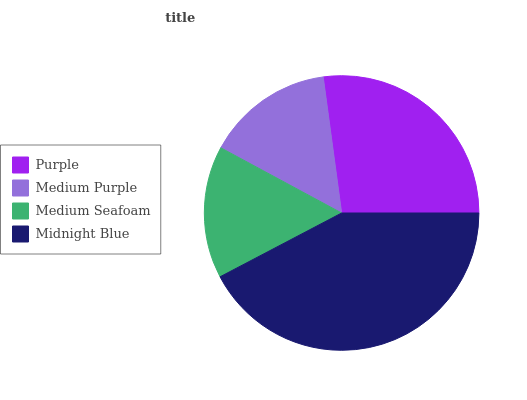Is Medium Purple the minimum?
Answer yes or no. Yes. Is Midnight Blue the maximum?
Answer yes or no. Yes. Is Medium Seafoam the minimum?
Answer yes or no. No. Is Medium Seafoam the maximum?
Answer yes or no. No. Is Medium Seafoam greater than Medium Purple?
Answer yes or no. Yes. Is Medium Purple less than Medium Seafoam?
Answer yes or no. Yes. Is Medium Purple greater than Medium Seafoam?
Answer yes or no. No. Is Medium Seafoam less than Medium Purple?
Answer yes or no. No. Is Purple the high median?
Answer yes or no. Yes. Is Medium Seafoam the low median?
Answer yes or no. Yes. Is Medium Purple the high median?
Answer yes or no. No. Is Midnight Blue the low median?
Answer yes or no. No. 